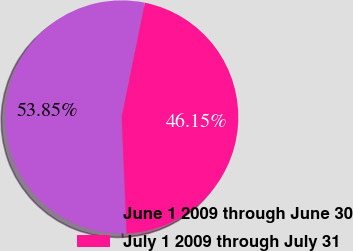<chart> <loc_0><loc_0><loc_500><loc_500><pie_chart><fcel>June 1 2009 through June 30<fcel>July 1 2009 through July 31<nl><fcel>53.85%<fcel>46.15%<nl></chart> 